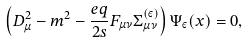<formula> <loc_0><loc_0><loc_500><loc_500>\left ( D _ { \mu } ^ { 2 } - m ^ { 2 } - \frac { e q } { 2 s } F _ { \mu \nu } \Sigma _ { \mu \nu } ^ { ( \varepsilon ) } \right ) \Psi _ { \varepsilon } ( x ) = 0 ,</formula> 